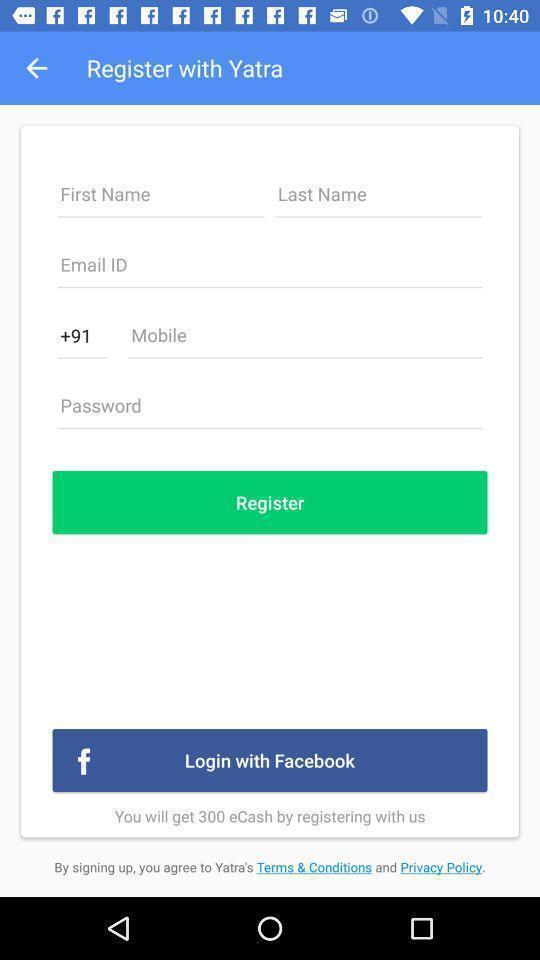Tell me what you see in this picture. Registration page for a travel app. 